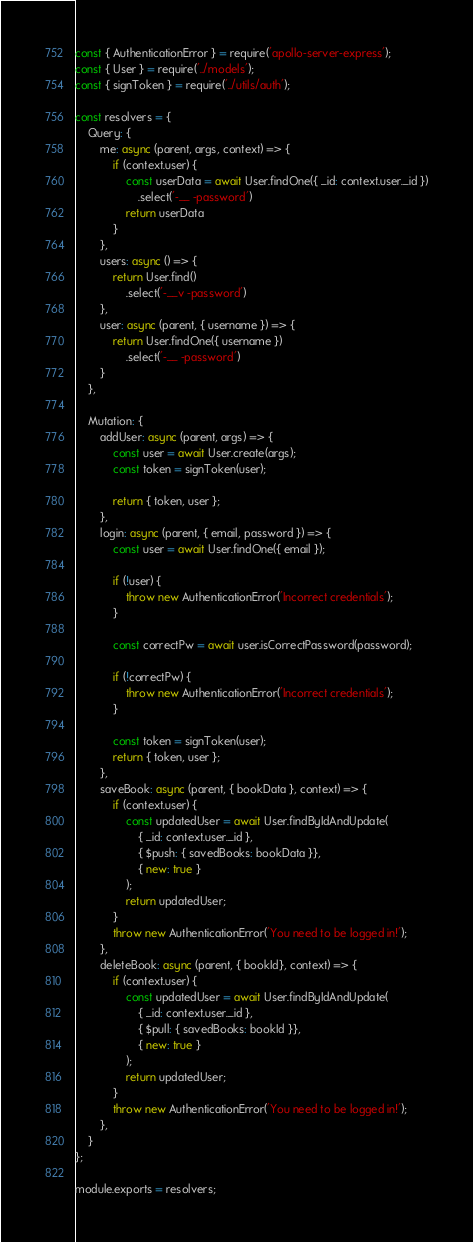<code> <loc_0><loc_0><loc_500><loc_500><_JavaScript_>const { AuthenticationError } = require('apollo-server-express');
const { User } = require('../models');
const { signToken } = require('../utils/auth');

const resolvers = {
    Query: {
        me: async (parent, args, context) => {
            if (context.user) {
                const userData = await User.findOne({ _id: context.user._id })
                    .select('-__ -password')
                return userData
            }
        },
        users: async () => {
            return User.find()
                .select('-__v -password')
        },
        user: async (parent, { username }) => {
            return User.findOne({ username })
                .select('-__ -password')
        }
    },

    Mutation: {
        addUser: async (parent, args) => {
            const user = await User.create(args);
            const token = signToken(user);

            return { token, user };
        },
        login: async (parent, { email, password }) => {
            const user = await User.findOne({ email });

            if (!user) {
                throw new AuthenticationError('Incorrect credentials');
            }

            const correctPw = await user.isCorrectPassword(password);

            if (!correctPw) {
                throw new AuthenticationError('Incorrect credentials');
            }

            const token = signToken(user);
            return { token, user }; 
        },
        saveBook: async (parent, { bookData }, context) => {
            if (context.user) {
                const updatedUser = await User.findByIdAndUpdate(
                    { _id: context.user._id },
                    { $push: { savedBooks: bookData }},
                    { new: true }
                );
                return updatedUser;
            }
            throw new AuthenticationError('You need to be logged in!');
        },
        deleteBook: async (parent, { bookId}, context) => {
            if (context.user) {
                const updatedUser = await User.findByIdAndUpdate(
                    { _id: context.user._id },
                    { $pull: { savedBooks: bookId }},
                    { new: true }
                );
                return updatedUser;
            }
            throw new AuthenticationError('You need to be logged in!');
        },
    }
};

module.exports = resolvers; </code> 